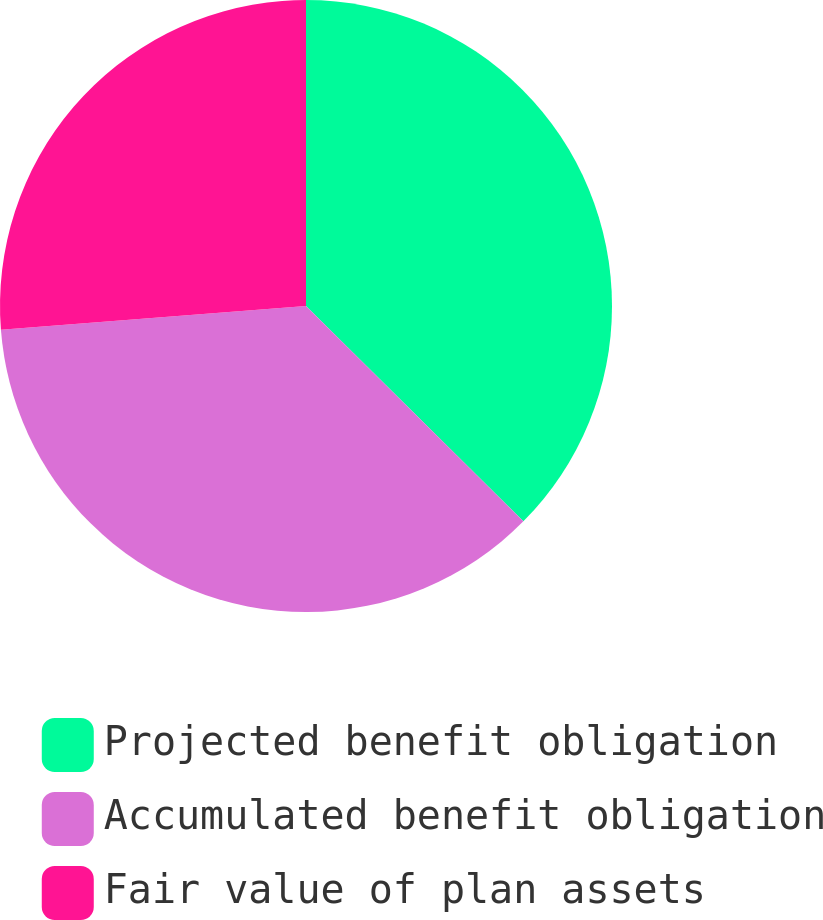Convert chart to OTSL. <chart><loc_0><loc_0><loc_500><loc_500><pie_chart><fcel>Projected benefit obligation<fcel>Accumulated benefit obligation<fcel>Fair value of plan assets<nl><fcel>37.43%<fcel>36.34%<fcel>26.24%<nl></chart> 